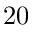Convert formula to latex. <formula><loc_0><loc_0><loc_500><loc_500>2 0</formula> 